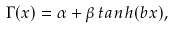Convert formula to latex. <formula><loc_0><loc_0><loc_500><loc_500>\Gamma ( x ) = \alpha + \beta \, t a n h ( b x ) ,</formula> 